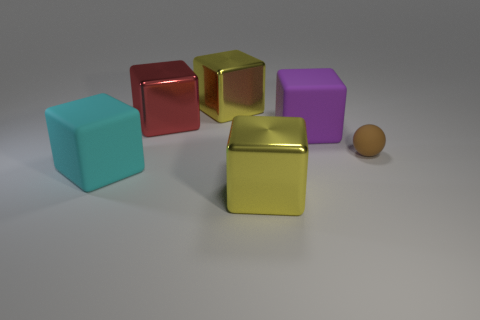How would you describe the overall composition and arrangement of the objects in this image? The image showcases a simple yet thoughtfully arranged composition of geometric shapes. It features a variety of colored blocks in different orientations with a matte or slightly shiny surface, and there is an underlying theme of geometry and balance. The spacing between the objects gives the scene an organized appearance while conveying a sense of three-dimensional space. 